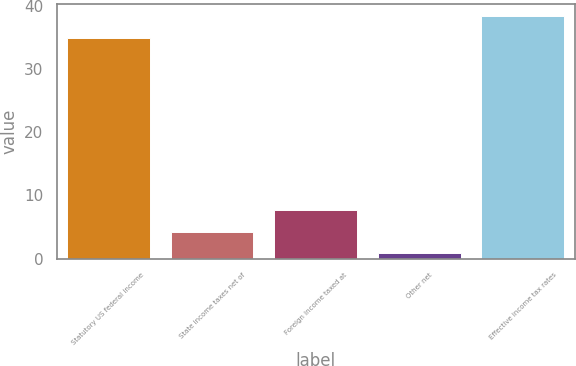<chart> <loc_0><loc_0><loc_500><loc_500><bar_chart><fcel>Statutory US federal income<fcel>State income taxes net of<fcel>Foreign income taxed at<fcel>Other net<fcel>Effective income tax rates<nl><fcel>35<fcel>4.27<fcel>7.74<fcel>0.8<fcel>38.47<nl></chart> 